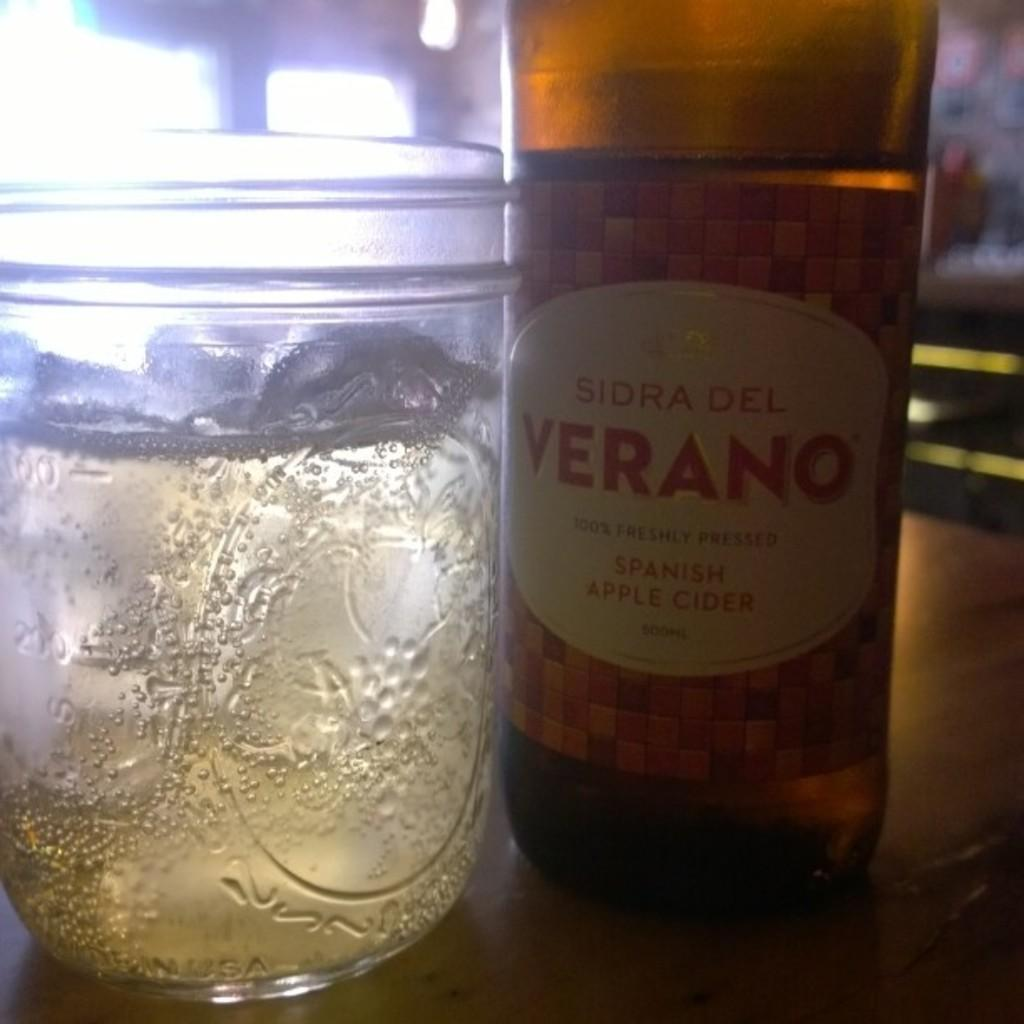<image>
Write a terse but informative summary of the picture. The bottle has a white label on it named Verano 